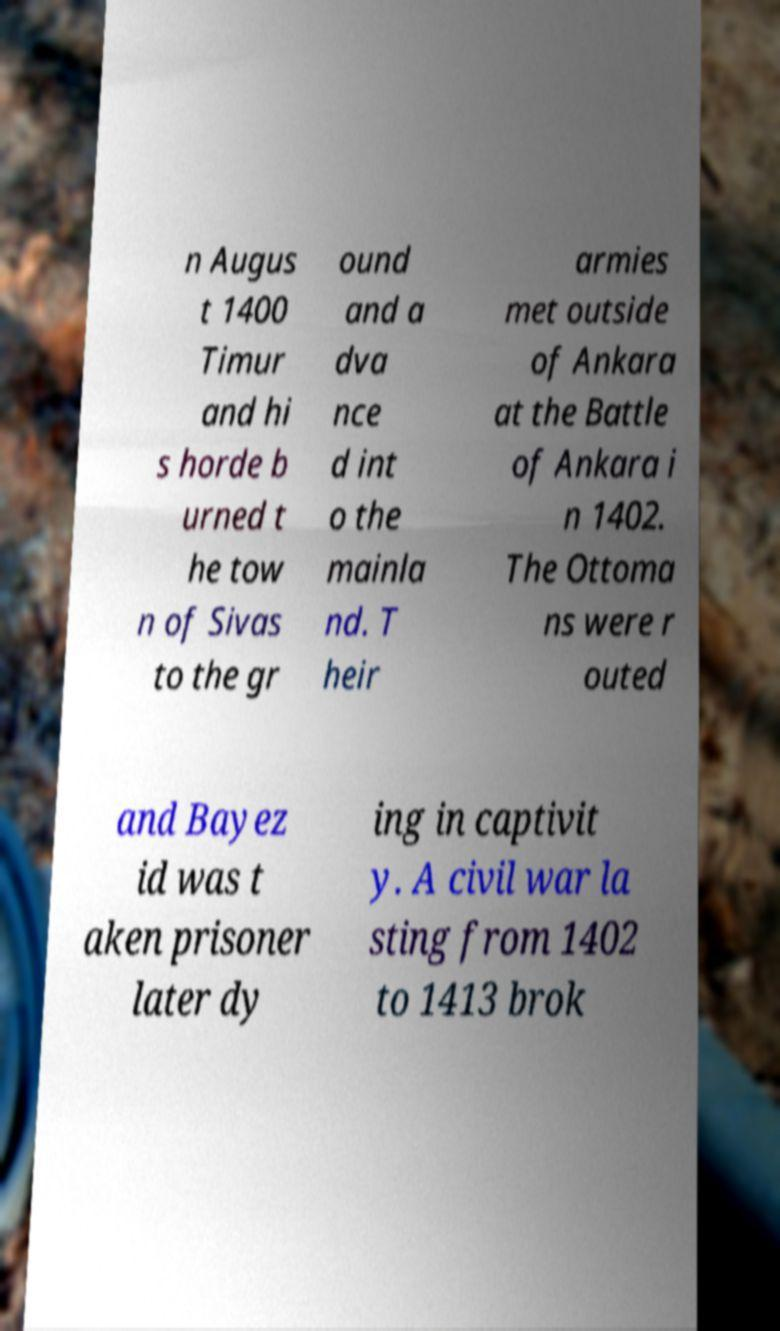For documentation purposes, I need the text within this image transcribed. Could you provide that? n Augus t 1400 Timur and hi s horde b urned t he tow n of Sivas to the gr ound and a dva nce d int o the mainla nd. T heir armies met outside of Ankara at the Battle of Ankara i n 1402. The Ottoma ns were r outed and Bayez id was t aken prisoner later dy ing in captivit y. A civil war la sting from 1402 to 1413 brok 